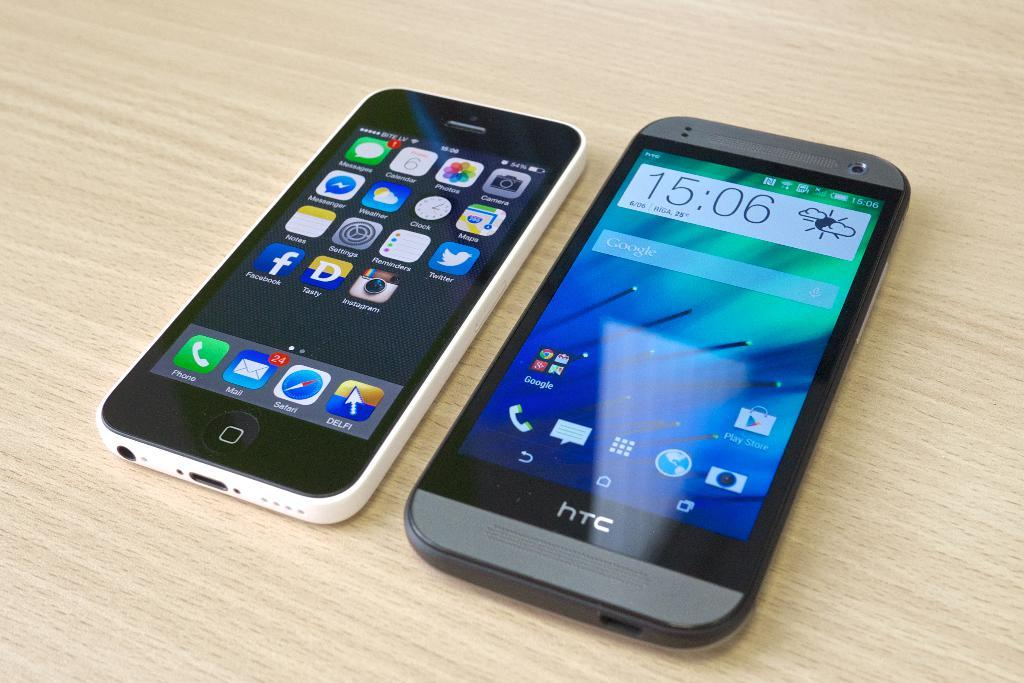<image>
Describe the image concisely. A gray htc cell phone lays next to another cell phone on a wood table. 